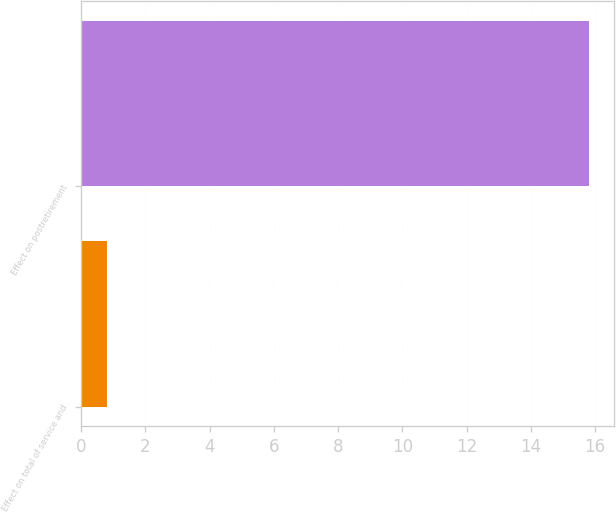Convert chart. <chart><loc_0><loc_0><loc_500><loc_500><bar_chart><fcel>Effect on total of service and<fcel>Effect on postretirement<nl><fcel>0.8<fcel>15.8<nl></chart> 